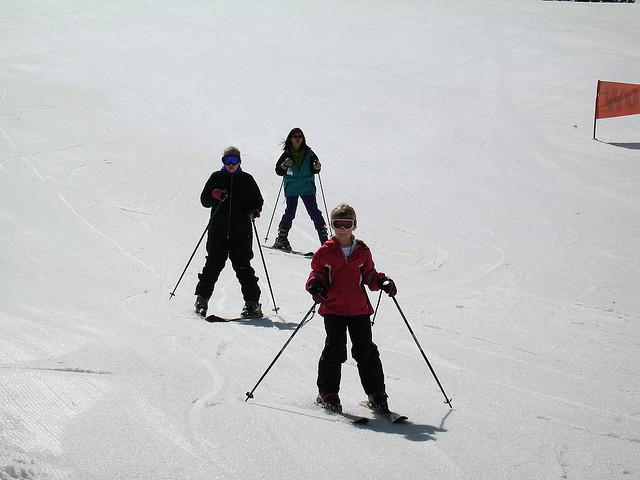What are the people doing?
Write a very short answer. Skiing. What country is this in?
Concise answer only. Usa. How many people in this photo are skiing?
Write a very short answer. 3. Does everyone have goggles on?
Quick response, please. Yes. How many people are on the slope?
Be succinct. 3. How many skiers?
Be succinct. 3. How many people are skiing?
Write a very short answer. 3. Is this person skiing on a bunny slope?
Keep it brief. Yes. Are the skiers going downhill?
Write a very short answer. Yes. How many people in the picture?
Keep it brief. 3. How many people are shown?
Be succinct. 3. Is this a competition?
Keep it brief. No. 